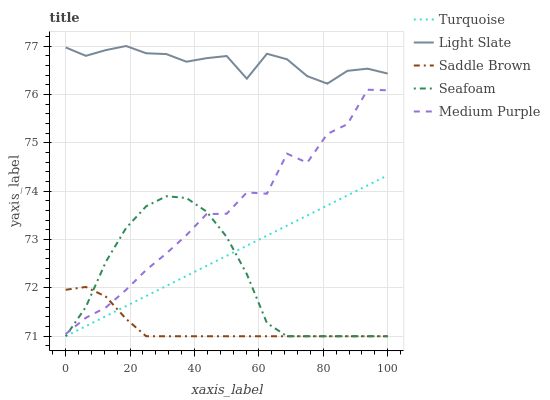Does Saddle Brown have the minimum area under the curve?
Answer yes or no. Yes. Does Light Slate have the maximum area under the curve?
Answer yes or no. Yes. Does Medium Purple have the minimum area under the curve?
Answer yes or no. No. Does Medium Purple have the maximum area under the curve?
Answer yes or no. No. Is Turquoise the smoothest?
Answer yes or no. Yes. Is Medium Purple the roughest?
Answer yes or no. Yes. Is Medium Purple the smoothest?
Answer yes or no. No. Is Turquoise the roughest?
Answer yes or no. No. Does Turquoise have the lowest value?
Answer yes or no. Yes. Does Medium Purple have the lowest value?
Answer yes or no. No. Does Light Slate have the highest value?
Answer yes or no. Yes. Does Medium Purple have the highest value?
Answer yes or no. No. Is Medium Purple less than Light Slate?
Answer yes or no. Yes. Is Medium Purple greater than Turquoise?
Answer yes or no. Yes. Does Turquoise intersect Saddle Brown?
Answer yes or no. Yes. Is Turquoise less than Saddle Brown?
Answer yes or no. No. Is Turquoise greater than Saddle Brown?
Answer yes or no. No. Does Medium Purple intersect Light Slate?
Answer yes or no. No. 